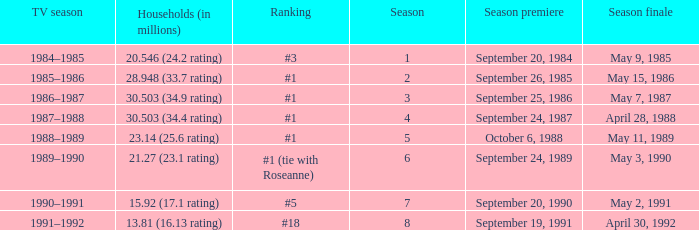Which TV season has a Season smaller than 8, and a Household (in millions) of 15.92 (17.1 rating)? 1990–1991. 